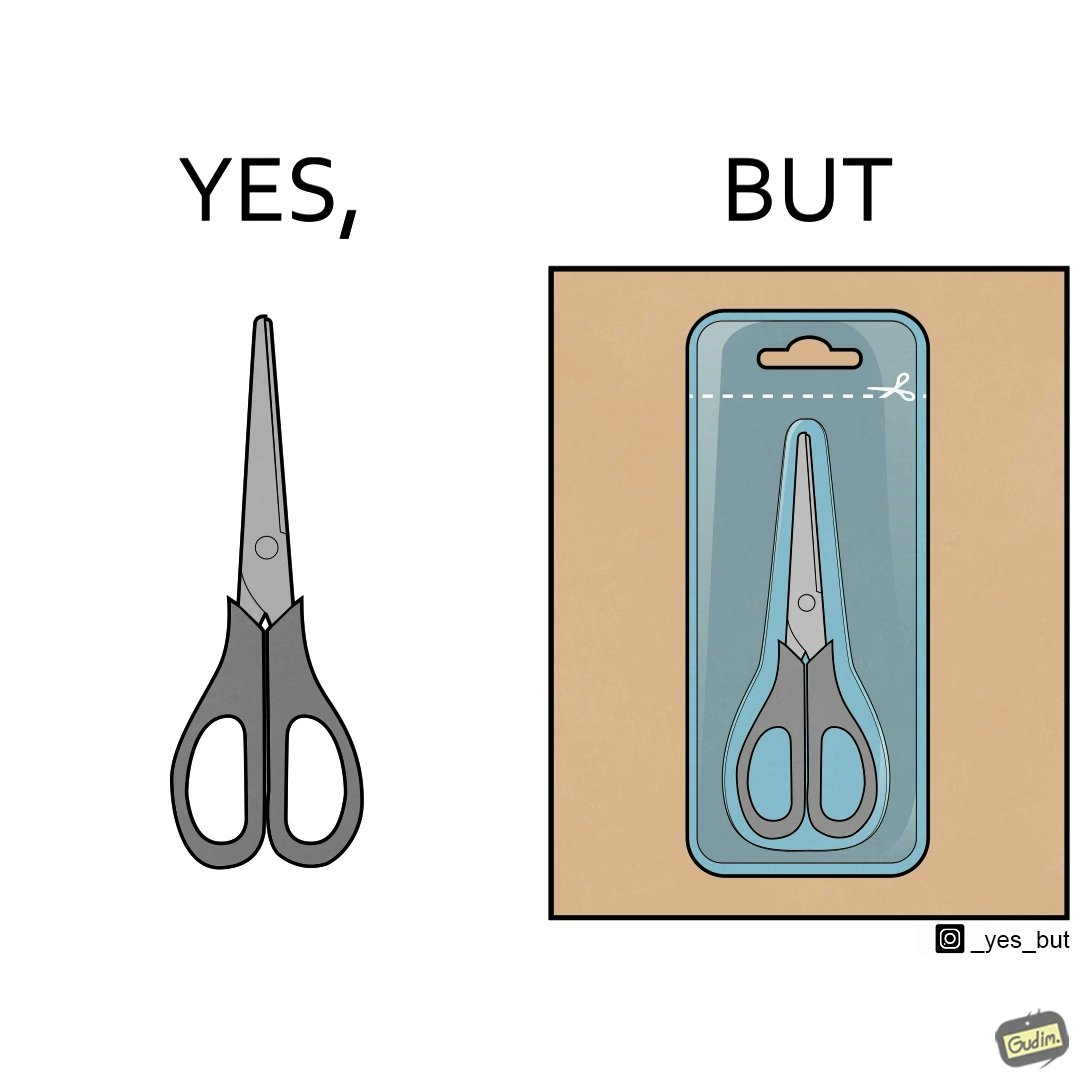Is there satirical content in this image? Yes, this image is satirical. 